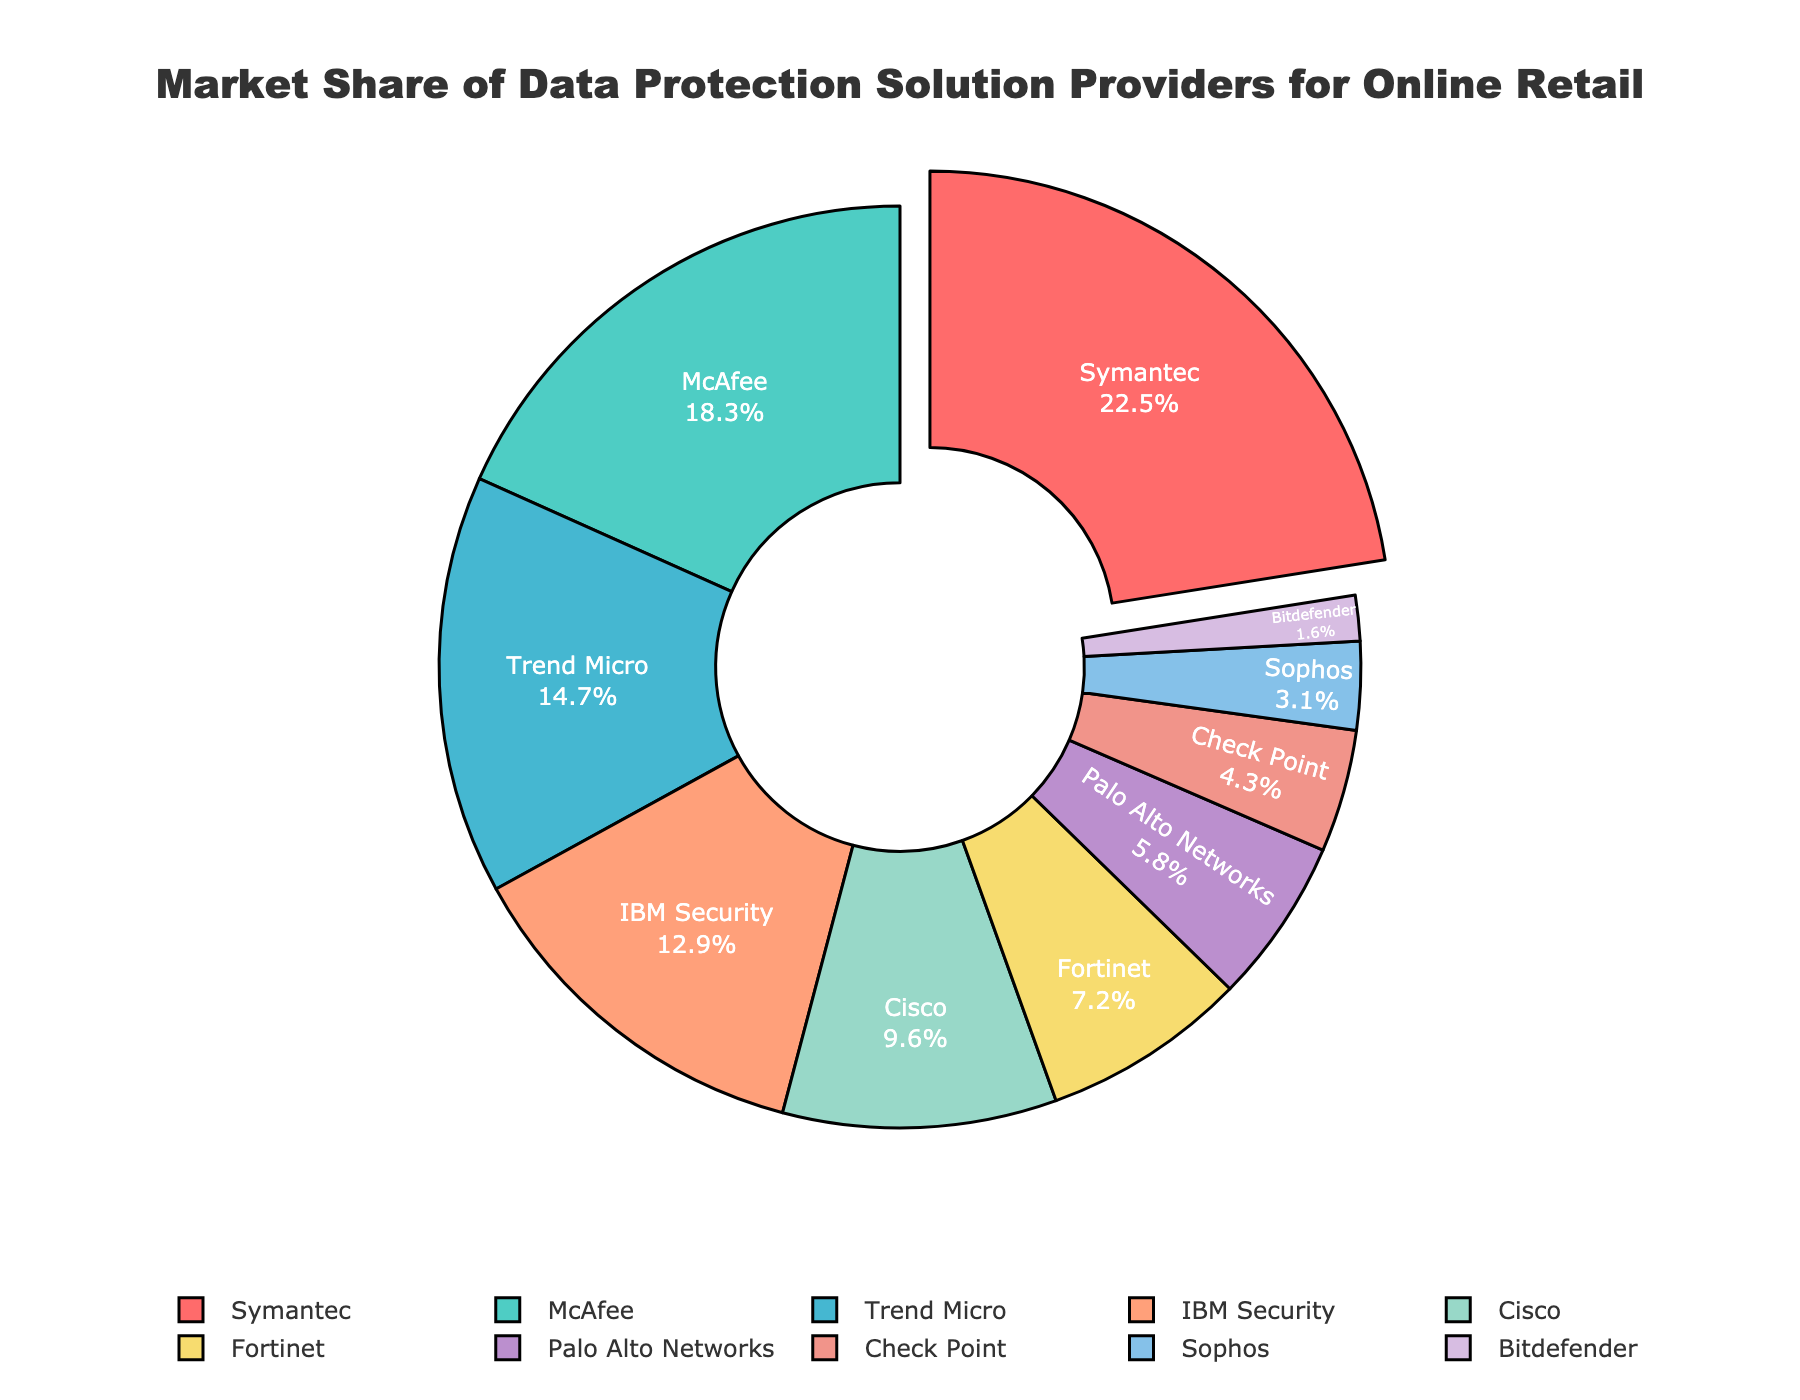What is the market share of the provider with the largest segment? Identify the largest segment in the pie chart and read the market share value associated with it, which is clearly labeled within the chart.
Answer: 22.5% Which provider has the smallest market share, and what is it? Locate the smallest segment in the pie chart and read the label and the associated market share value.
Answer: Bitdefender, 1.6% How does Symantec's market share compare to McAfee's? Identify the segments for Symantec and McAfee, then compare their market share percentages. Symantec has a larger market share than McAfee.
Answer: Symantec has a larger market share What is the combined market share of the top three providers? Identify the top three providers with the largest market shares and add their percentages together: Symantec (22.5%) + McAfee (18.3%) + Trend Micro (14.7%)
Answer: 55.5% What percentage of the market is covered by providers with a market share of 10% or more? Select the providers with market shares of 10% or more: Symantec, McAfee, Trend Micro, and IBM Security. Add their percentages together: 22.5% + 18.3% + 14.7% + 12.9%
Answer: 68.4% Which segment represents 9.6% of the market? Locate and read the segment labeled as 9.6% to identify the provider.
Answer: Cisco How much larger is Cisco's market share compared to Fortinet's? Subtract Fortinet's market share from Cisco's: 9.6% - 7.2%
Answer: 2.4% What is the average market share of all providers listed? Sum all the provided market shares and divide by the number of providers. (22.5% + 18.3% + 14.7% + 12.9% + 9.6% + 7.2% + 5.8% + 4.3% + 3.1% + 1.6%) / 10
Answer: 10% What colors are used to represent Symantec and McAfee? Identify the colors used for the segments labeled Symantec and McAfee in the pie chart.
Answer: Symantec is red; McAfee is turquoise 